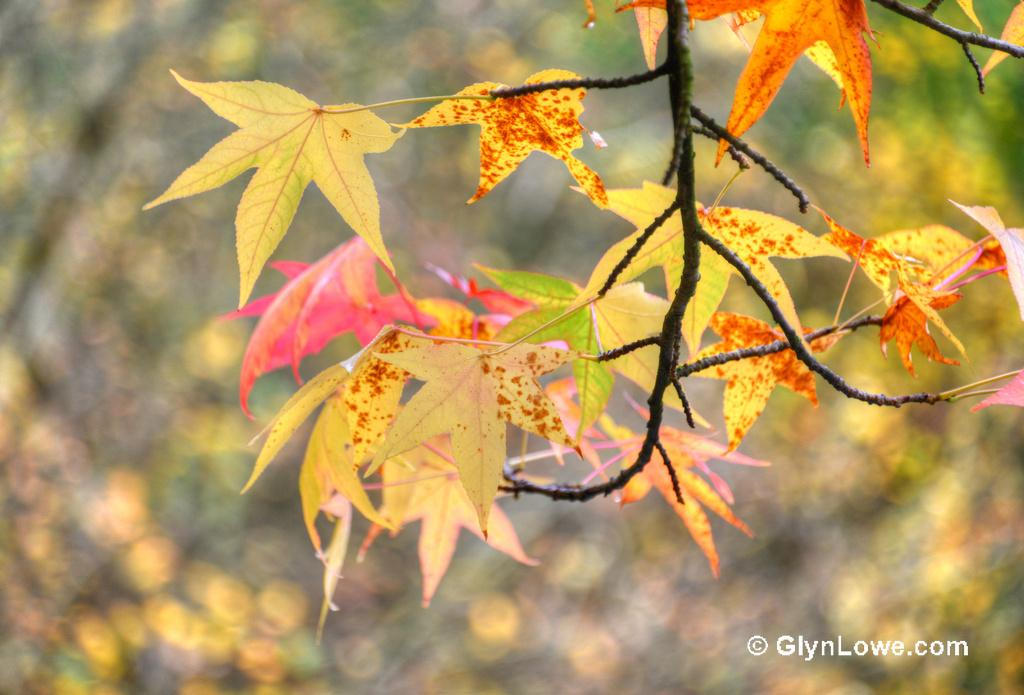What is the main subject of the image? The main subject of the image is a branch of a tree. Can you describe the branch in the image? The branch has some leaves. How would you describe the background of the image? The background of the image is blurred. What type of punishment is being administered in the image? There is no punishment being administered in the image; it features a branch of a tree with leaves. What is the rifle being used for in the image? There is no rifle present in the image. 